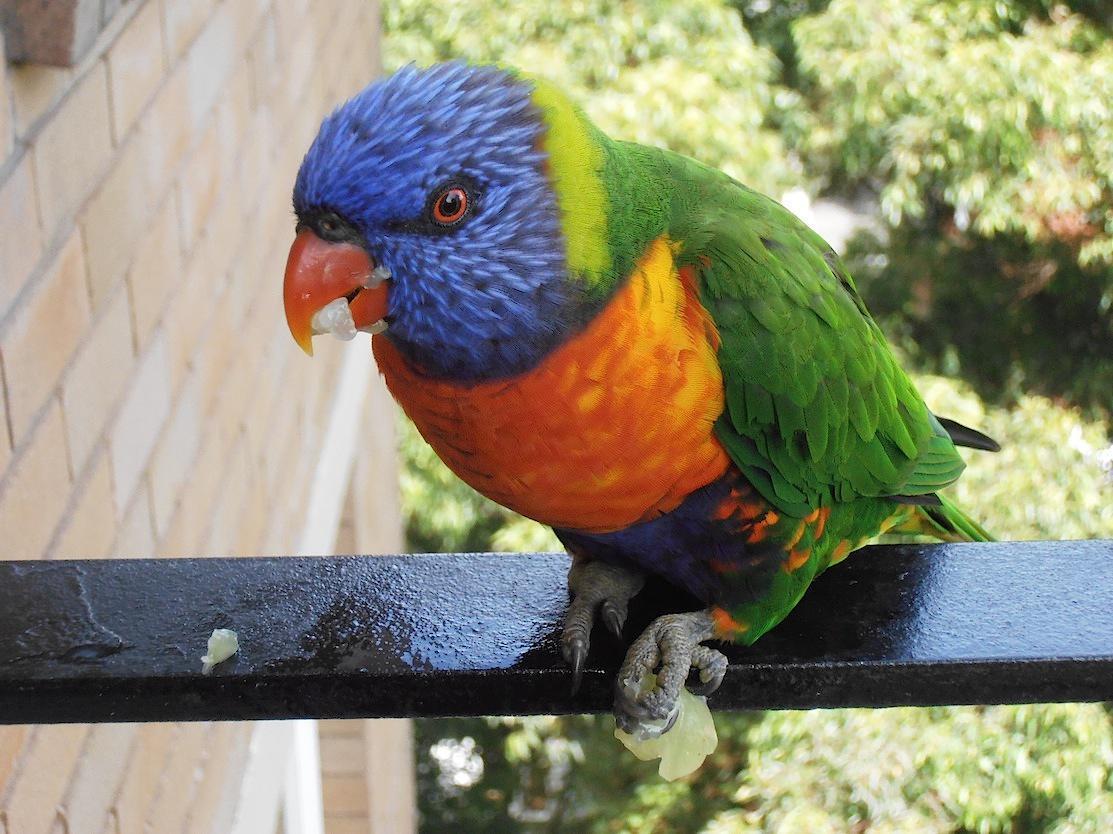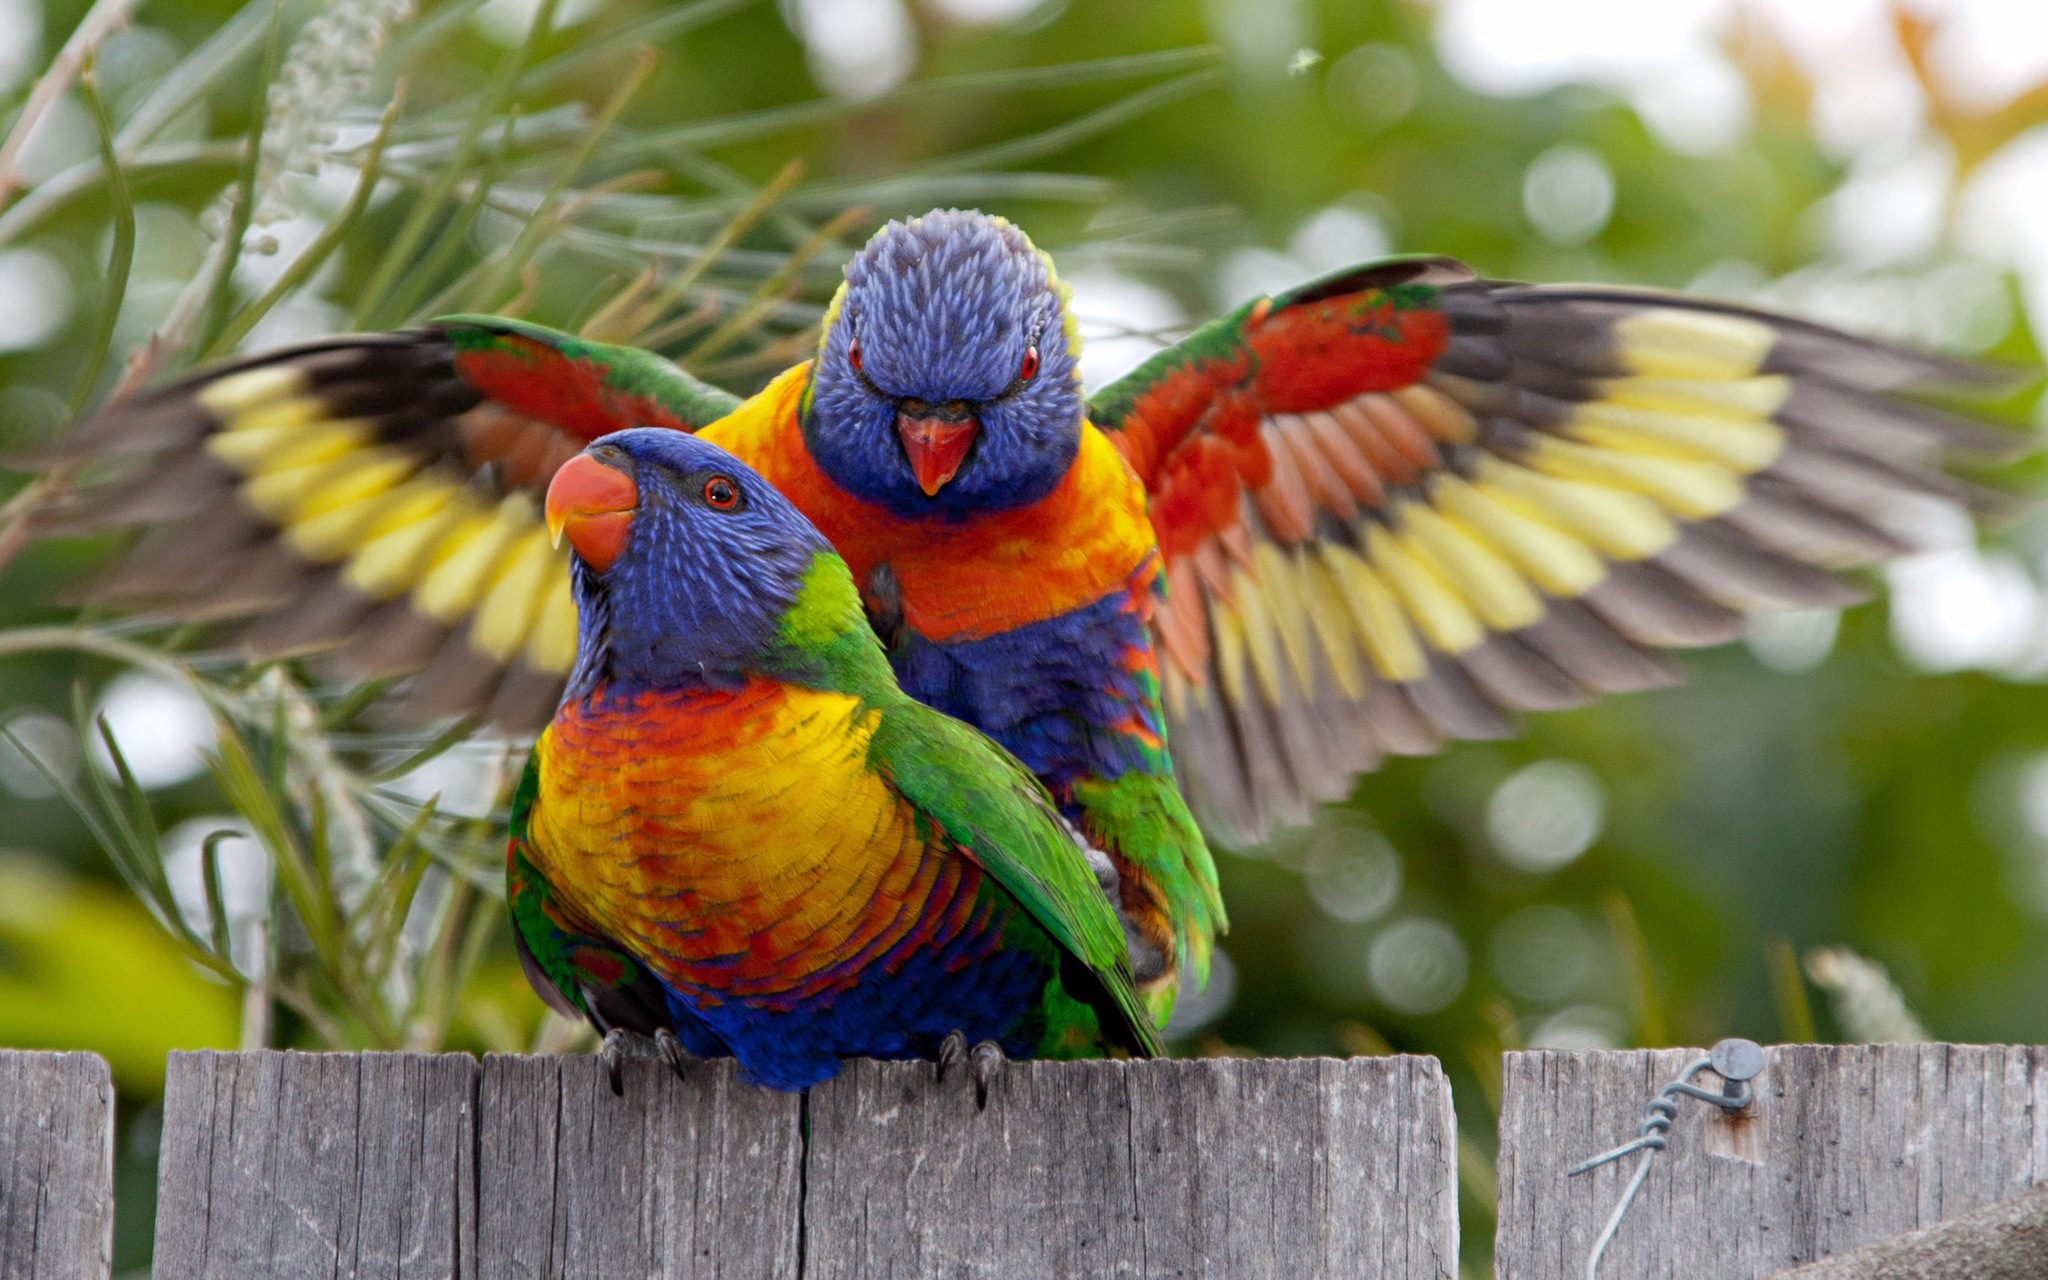The first image is the image on the left, the second image is the image on the right. For the images shown, is this caption "There is at least two parrots in the right image." true? Answer yes or no. Yes. The first image is the image on the left, the second image is the image on the right. For the images shown, is this caption "At least one image shows a colorful bird interacting with a human hand" true? Answer yes or no. No. 